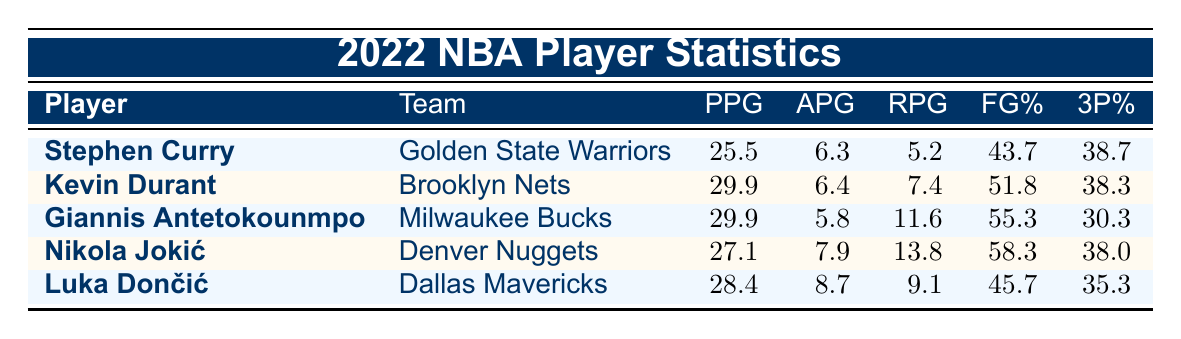What is Stephen Curry's points per game in the 2022 season? Stephen Curry's statistics are listed in the table, and his points per game (PPG) shows as 25.5.
Answer: 25.5 Which player had the highest field goal percentage? Comparing the field goal percentages in the table, Nikola Jokić has the highest at 58.3%.
Answer: 58.3 What is the average points per game of Giannis Antetokounmpo and Luka Dončić? The points per game for Giannis Antetokounmpo is 29.9 and for Luka Dončić is 28.4. Adding these gives 29.9 + 28.4 = 58.3. Dividing by 2 for the average gives 58.3/2 = 29.15.
Answer: 29.15 Did any player record more rebounds per game than Stephen Curry? Stephen Curry has 5.2 rebounds per game. Examining the other players, Giannis Antetokounmpo (11.6) and Nikola Jokić (13.8) both have more rebounds per game than Stephen Curry.
Answer: Yes Which player has the highest assists per game and what is that value? The assists per game for each player are compared, with Luka Dončić having the highest at 8.7 assists per game.
Answer: 8.7 What is the difference in points per game between Kevin Durant and Nikola Jokić? Kevin Durant's points per game is 29.9, while Nikola Jokić's is 27.1. The difference is calculated as 29.9 - 27.1 = 2.8.
Answer: 2.8 Is Giannis Antetokounmpo's three-point percentage higher than Stephen Curry's? Giannis Antetokounmpo's three-point percentage is 30.3%, while Stephen Curry's is 38.7%. Thus, Giannis's percentage is not higher than Curry's.
Answer: No What is the total number of assists per game from all players combined? The assists per game for each player is summed: 6.3 (Curry) + 6.4 (Durant) + 5.8 (Giannis) + 7.9 (Jokić) + 8.7 (Dončić) = 35.1.
Answer: 35.1 